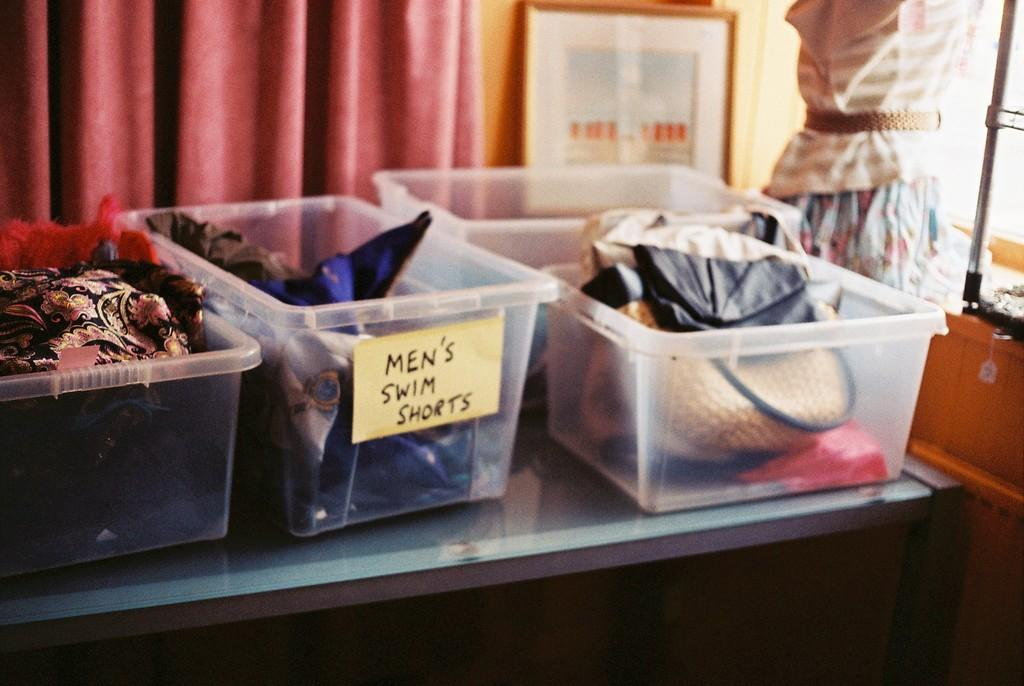<image>
Create a compact narrative representing the image presented. mens swim shorts plastic bin among other clothes in plastic bucket 